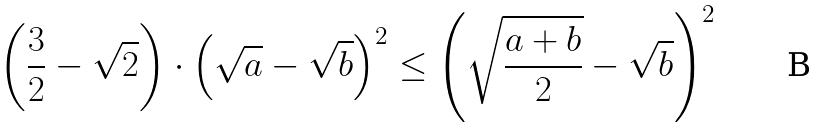Convert formula to latex. <formula><loc_0><loc_0><loc_500><loc_500>\left ( \frac { 3 } { 2 } - \sqrt { 2 } \right ) \cdot \left ( \sqrt { a } - \sqrt { b } \right ) ^ { 2 } \leq \left ( \sqrt { \frac { a + b } { 2 } } - \sqrt { b } \right ) ^ { 2 }</formula> 